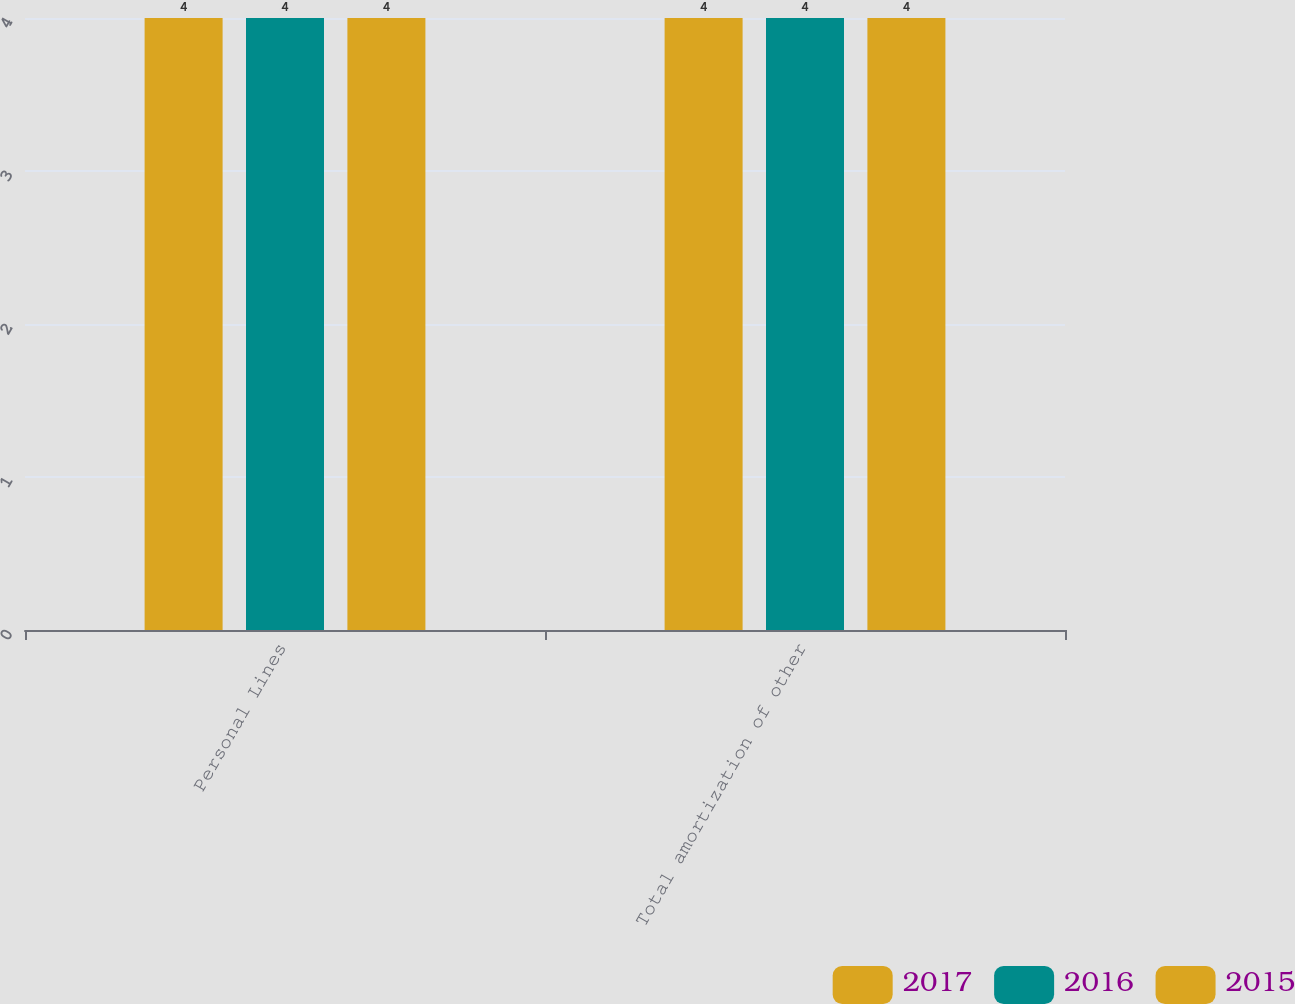<chart> <loc_0><loc_0><loc_500><loc_500><stacked_bar_chart><ecel><fcel>Personal Lines<fcel>Total amortization of other<nl><fcel>2017<fcel>4<fcel>4<nl><fcel>2016<fcel>4<fcel>4<nl><fcel>2015<fcel>4<fcel>4<nl></chart> 